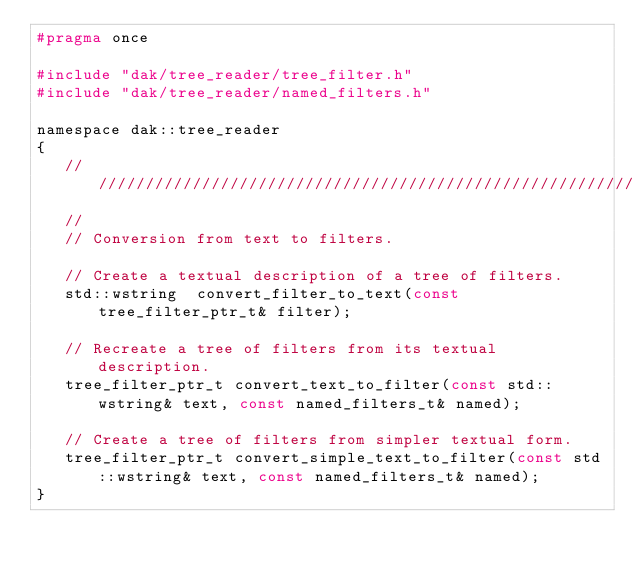<code> <loc_0><loc_0><loc_500><loc_500><_C_>#pragma once

#include "dak/tree_reader/tree_filter.h"
#include "dak/tree_reader/named_filters.h"

namespace dak::tree_reader
{
   ////////////////////////////////////////////////////////////////////////////
   //
   // Conversion from text to filters.

   // Create a textual description of a tree of filters.
   std::wstring  convert_filter_to_text(const tree_filter_ptr_t& filter);

   // Recreate a tree of filters from its textual description.
   tree_filter_ptr_t convert_text_to_filter(const std::wstring& text, const named_filters_t& named);

   // Create a tree of filters from simpler textual form.
   tree_filter_ptr_t convert_simple_text_to_filter(const std::wstring& text, const named_filters_t& named);
}
</code> 